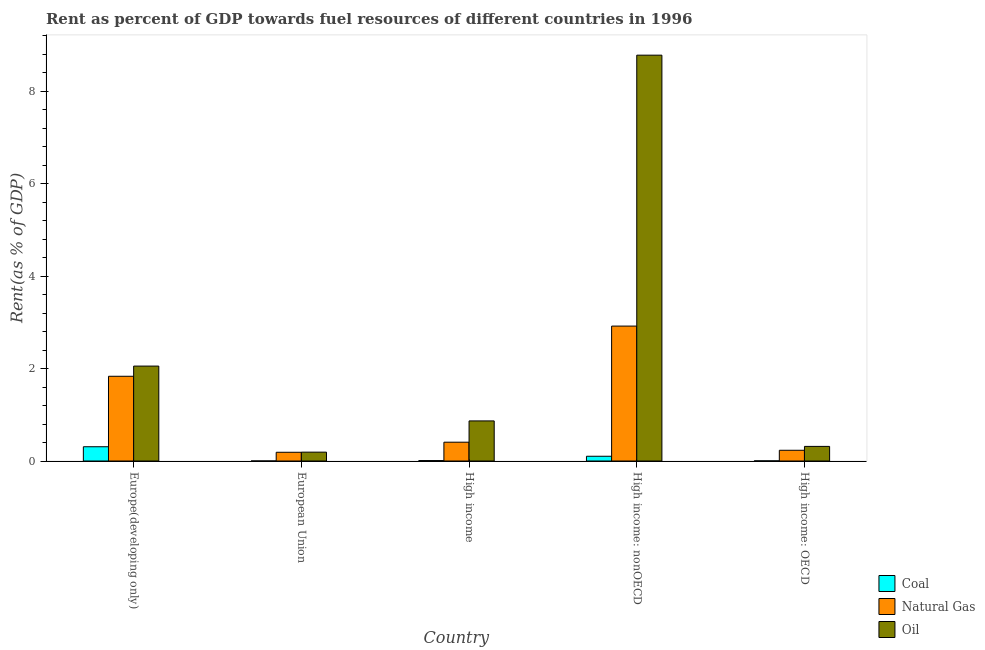How many different coloured bars are there?
Ensure brevity in your answer.  3. How many groups of bars are there?
Make the answer very short. 5. How many bars are there on the 2nd tick from the left?
Your response must be concise. 3. What is the label of the 3rd group of bars from the left?
Offer a terse response. High income. In how many cases, is the number of bars for a given country not equal to the number of legend labels?
Provide a short and direct response. 0. What is the rent towards oil in Europe(developing only)?
Offer a terse response. 2.05. Across all countries, what is the maximum rent towards natural gas?
Offer a very short reply. 2.92. Across all countries, what is the minimum rent towards coal?
Make the answer very short. 0. In which country was the rent towards natural gas maximum?
Provide a short and direct response. High income: nonOECD. What is the total rent towards oil in the graph?
Your response must be concise. 12.21. What is the difference between the rent towards coal in High income and that in High income: OECD?
Make the answer very short. 0.01. What is the difference between the rent towards oil in High income: OECD and the rent towards natural gas in High income?
Keep it short and to the point. -0.09. What is the average rent towards oil per country?
Ensure brevity in your answer.  2.44. What is the difference between the rent towards natural gas and rent towards coal in European Union?
Your response must be concise. 0.19. What is the ratio of the rent towards coal in Europe(developing only) to that in High income: nonOECD?
Your response must be concise. 3. Is the rent towards natural gas in High income less than that in High income: nonOECD?
Ensure brevity in your answer.  Yes. What is the difference between the highest and the second highest rent towards natural gas?
Your answer should be compact. 1.09. What is the difference between the highest and the lowest rent towards natural gas?
Provide a short and direct response. 2.73. What does the 2nd bar from the left in European Union represents?
Ensure brevity in your answer.  Natural Gas. What does the 3rd bar from the right in High income: nonOECD represents?
Offer a terse response. Coal. Is it the case that in every country, the sum of the rent towards coal and rent towards natural gas is greater than the rent towards oil?
Your answer should be compact. No. How many bars are there?
Make the answer very short. 15. Are all the bars in the graph horizontal?
Provide a short and direct response. No. Are the values on the major ticks of Y-axis written in scientific E-notation?
Provide a succinct answer. No. What is the title of the graph?
Make the answer very short. Rent as percent of GDP towards fuel resources of different countries in 1996. What is the label or title of the X-axis?
Make the answer very short. Country. What is the label or title of the Y-axis?
Your response must be concise. Rent(as % of GDP). What is the Rent(as % of GDP) of Coal in Europe(developing only)?
Keep it short and to the point. 0.31. What is the Rent(as % of GDP) of Natural Gas in Europe(developing only)?
Ensure brevity in your answer.  1.83. What is the Rent(as % of GDP) in Oil in Europe(developing only)?
Offer a very short reply. 2.05. What is the Rent(as % of GDP) of Coal in European Union?
Offer a very short reply. 0. What is the Rent(as % of GDP) of Natural Gas in European Union?
Give a very brief answer. 0.19. What is the Rent(as % of GDP) in Oil in European Union?
Keep it short and to the point. 0.19. What is the Rent(as % of GDP) of Coal in High income?
Your response must be concise. 0.01. What is the Rent(as % of GDP) of Natural Gas in High income?
Ensure brevity in your answer.  0.41. What is the Rent(as % of GDP) in Oil in High income?
Ensure brevity in your answer.  0.87. What is the Rent(as % of GDP) of Coal in High income: nonOECD?
Your answer should be compact. 0.1. What is the Rent(as % of GDP) in Natural Gas in High income: nonOECD?
Offer a very short reply. 2.92. What is the Rent(as % of GDP) of Oil in High income: nonOECD?
Provide a short and direct response. 8.78. What is the Rent(as % of GDP) of Coal in High income: OECD?
Keep it short and to the point. 0. What is the Rent(as % of GDP) of Natural Gas in High income: OECD?
Provide a short and direct response. 0.23. What is the Rent(as % of GDP) in Oil in High income: OECD?
Provide a succinct answer. 0.32. Across all countries, what is the maximum Rent(as % of GDP) in Coal?
Keep it short and to the point. 0.31. Across all countries, what is the maximum Rent(as % of GDP) in Natural Gas?
Give a very brief answer. 2.92. Across all countries, what is the maximum Rent(as % of GDP) of Oil?
Give a very brief answer. 8.78. Across all countries, what is the minimum Rent(as % of GDP) in Coal?
Your answer should be very brief. 0. Across all countries, what is the minimum Rent(as % of GDP) of Natural Gas?
Offer a terse response. 0.19. Across all countries, what is the minimum Rent(as % of GDP) in Oil?
Your answer should be very brief. 0.19. What is the total Rent(as % of GDP) of Coal in the graph?
Your answer should be very brief. 0.42. What is the total Rent(as % of GDP) of Natural Gas in the graph?
Ensure brevity in your answer.  5.58. What is the total Rent(as % of GDP) of Oil in the graph?
Your answer should be compact. 12.21. What is the difference between the Rent(as % of GDP) of Coal in Europe(developing only) and that in European Union?
Make the answer very short. 0.31. What is the difference between the Rent(as % of GDP) in Natural Gas in Europe(developing only) and that in European Union?
Offer a terse response. 1.64. What is the difference between the Rent(as % of GDP) in Oil in Europe(developing only) and that in European Union?
Keep it short and to the point. 1.86. What is the difference between the Rent(as % of GDP) in Coal in Europe(developing only) and that in High income?
Provide a short and direct response. 0.3. What is the difference between the Rent(as % of GDP) of Natural Gas in Europe(developing only) and that in High income?
Ensure brevity in your answer.  1.43. What is the difference between the Rent(as % of GDP) of Oil in Europe(developing only) and that in High income?
Keep it short and to the point. 1.19. What is the difference between the Rent(as % of GDP) in Coal in Europe(developing only) and that in High income: nonOECD?
Provide a short and direct response. 0.21. What is the difference between the Rent(as % of GDP) in Natural Gas in Europe(developing only) and that in High income: nonOECD?
Your answer should be very brief. -1.09. What is the difference between the Rent(as % of GDP) of Oil in Europe(developing only) and that in High income: nonOECD?
Provide a short and direct response. -6.72. What is the difference between the Rent(as % of GDP) of Coal in Europe(developing only) and that in High income: OECD?
Make the answer very short. 0.31. What is the difference between the Rent(as % of GDP) in Natural Gas in Europe(developing only) and that in High income: OECD?
Make the answer very short. 1.6. What is the difference between the Rent(as % of GDP) in Oil in Europe(developing only) and that in High income: OECD?
Offer a terse response. 1.74. What is the difference between the Rent(as % of GDP) of Coal in European Union and that in High income?
Your answer should be compact. -0.01. What is the difference between the Rent(as % of GDP) in Natural Gas in European Union and that in High income?
Your answer should be very brief. -0.22. What is the difference between the Rent(as % of GDP) in Oil in European Union and that in High income?
Provide a short and direct response. -0.68. What is the difference between the Rent(as % of GDP) of Coal in European Union and that in High income: nonOECD?
Your answer should be very brief. -0.1. What is the difference between the Rent(as % of GDP) of Natural Gas in European Union and that in High income: nonOECD?
Your answer should be compact. -2.73. What is the difference between the Rent(as % of GDP) of Oil in European Union and that in High income: nonOECD?
Your response must be concise. -8.59. What is the difference between the Rent(as % of GDP) in Coal in European Union and that in High income: OECD?
Provide a succinct answer. -0. What is the difference between the Rent(as % of GDP) in Natural Gas in European Union and that in High income: OECD?
Your answer should be compact. -0.04. What is the difference between the Rent(as % of GDP) of Oil in European Union and that in High income: OECD?
Your answer should be compact. -0.12. What is the difference between the Rent(as % of GDP) of Coal in High income and that in High income: nonOECD?
Your answer should be compact. -0.09. What is the difference between the Rent(as % of GDP) in Natural Gas in High income and that in High income: nonOECD?
Your answer should be compact. -2.51. What is the difference between the Rent(as % of GDP) of Oil in High income and that in High income: nonOECD?
Provide a short and direct response. -7.91. What is the difference between the Rent(as % of GDP) of Coal in High income and that in High income: OECD?
Your answer should be very brief. 0.01. What is the difference between the Rent(as % of GDP) in Natural Gas in High income and that in High income: OECD?
Provide a short and direct response. 0.17. What is the difference between the Rent(as % of GDP) of Oil in High income and that in High income: OECD?
Your response must be concise. 0.55. What is the difference between the Rent(as % of GDP) of Coal in High income: nonOECD and that in High income: OECD?
Your answer should be compact. 0.1. What is the difference between the Rent(as % of GDP) of Natural Gas in High income: nonOECD and that in High income: OECD?
Your response must be concise. 2.69. What is the difference between the Rent(as % of GDP) of Oil in High income: nonOECD and that in High income: OECD?
Ensure brevity in your answer.  8.46. What is the difference between the Rent(as % of GDP) of Coal in Europe(developing only) and the Rent(as % of GDP) of Natural Gas in European Union?
Your answer should be very brief. 0.12. What is the difference between the Rent(as % of GDP) of Coal in Europe(developing only) and the Rent(as % of GDP) of Oil in European Union?
Provide a short and direct response. 0.12. What is the difference between the Rent(as % of GDP) of Natural Gas in Europe(developing only) and the Rent(as % of GDP) of Oil in European Union?
Provide a short and direct response. 1.64. What is the difference between the Rent(as % of GDP) in Coal in Europe(developing only) and the Rent(as % of GDP) in Natural Gas in High income?
Make the answer very short. -0.1. What is the difference between the Rent(as % of GDP) of Coal in Europe(developing only) and the Rent(as % of GDP) of Oil in High income?
Keep it short and to the point. -0.56. What is the difference between the Rent(as % of GDP) of Natural Gas in Europe(developing only) and the Rent(as % of GDP) of Oil in High income?
Offer a terse response. 0.97. What is the difference between the Rent(as % of GDP) in Coal in Europe(developing only) and the Rent(as % of GDP) in Natural Gas in High income: nonOECD?
Offer a terse response. -2.61. What is the difference between the Rent(as % of GDP) in Coal in Europe(developing only) and the Rent(as % of GDP) in Oil in High income: nonOECD?
Keep it short and to the point. -8.47. What is the difference between the Rent(as % of GDP) of Natural Gas in Europe(developing only) and the Rent(as % of GDP) of Oil in High income: nonOECD?
Offer a terse response. -6.95. What is the difference between the Rent(as % of GDP) in Coal in Europe(developing only) and the Rent(as % of GDP) in Natural Gas in High income: OECD?
Offer a terse response. 0.08. What is the difference between the Rent(as % of GDP) in Coal in Europe(developing only) and the Rent(as % of GDP) in Oil in High income: OECD?
Ensure brevity in your answer.  -0.01. What is the difference between the Rent(as % of GDP) of Natural Gas in Europe(developing only) and the Rent(as % of GDP) of Oil in High income: OECD?
Keep it short and to the point. 1.52. What is the difference between the Rent(as % of GDP) of Coal in European Union and the Rent(as % of GDP) of Natural Gas in High income?
Your response must be concise. -0.41. What is the difference between the Rent(as % of GDP) of Coal in European Union and the Rent(as % of GDP) of Oil in High income?
Offer a terse response. -0.87. What is the difference between the Rent(as % of GDP) in Natural Gas in European Union and the Rent(as % of GDP) in Oil in High income?
Your answer should be very brief. -0.68. What is the difference between the Rent(as % of GDP) in Coal in European Union and the Rent(as % of GDP) in Natural Gas in High income: nonOECD?
Ensure brevity in your answer.  -2.92. What is the difference between the Rent(as % of GDP) of Coal in European Union and the Rent(as % of GDP) of Oil in High income: nonOECD?
Your answer should be compact. -8.78. What is the difference between the Rent(as % of GDP) in Natural Gas in European Union and the Rent(as % of GDP) in Oil in High income: nonOECD?
Your answer should be compact. -8.59. What is the difference between the Rent(as % of GDP) of Coal in European Union and the Rent(as % of GDP) of Natural Gas in High income: OECD?
Offer a very short reply. -0.23. What is the difference between the Rent(as % of GDP) in Coal in European Union and the Rent(as % of GDP) in Oil in High income: OECD?
Offer a very short reply. -0.32. What is the difference between the Rent(as % of GDP) in Natural Gas in European Union and the Rent(as % of GDP) in Oil in High income: OECD?
Your response must be concise. -0.13. What is the difference between the Rent(as % of GDP) of Coal in High income and the Rent(as % of GDP) of Natural Gas in High income: nonOECD?
Keep it short and to the point. -2.91. What is the difference between the Rent(as % of GDP) in Coal in High income and the Rent(as % of GDP) in Oil in High income: nonOECD?
Provide a succinct answer. -8.77. What is the difference between the Rent(as % of GDP) of Natural Gas in High income and the Rent(as % of GDP) of Oil in High income: nonOECD?
Provide a short and direct response. -8.37. What is the difference between the Rent(as % of GDP) in Coal in High income and the Rent(as % of GDP) in Natural Gas in High income: OECD?
Provide a short and direct response. -0.22. What is the difference between the Rent(as % of GDP) in Coal in High income and the Rent(as % of GDP) in Oil in High income: OECD?
Make the answer very short. -0.31. What is the difference between the Rent(as % of GDP) of Natural Gas in High income and the Rent(as % of GDP) of Oil in High income: OECD?
Offer a very short reply. 0.09. What is the difference between the Rent(as % of GDP) in Coal in High income: nonOECD and the Rent(as % of GDP) in Natural Gas in High income: OECD?
Keep it short and to the point. -0.13. What is the difference between the Rent(as % of GDP) in Coal in High income: nonOECD and the Rent(as % of GDP) in Oil in High income: OECD?
Offer a terse response. -0.21. What is the difference between the Rent(as % of GDP) of Natural Gas in High income: nonOECD and the Rent(as % of GDP) of Oil in High income: OECD?
Your response must be concise. 2.6. What is the average Rent(as % of GDP) in Coal per country?
Give a very brief answer. 0.08. What is the average Rent(as % of GDP) in Natural Gas per country?
Offer a very short reply. 1.12. What is the average Rent(as % of GDP) in Oil per country?
Offer a very short reply. 2.44. What is the difference between the Rent(as % of GDP) in Coal and Rent(as % of GDP) in Natural Gas in Europe(developing only)?
Your answer should be compact. -1.52. What is the difference between the Rent(as % of GDP) in Coal and Rent(as % of GDP) in Oil in Europe(developing only)?
Provide a short and direct response. -1.74. What is the difference between the Rent(as % of GDP) of Natural Gas and Rent(as % of GDP) of Oil in Europe(developing only)?
Give a very brief answer. -0.22. What is the difference between the Rent(as % of GDP) in Coal and Rent(as % of GDP) in Natural Gas in European Union?
Keep it short and to the point. -0.19. What is the difference between the Rent(as % of GDP) of Coal and Rent(as % of GDP) of Oil in European Union?
Offer a terse response. -0.19. What is the difference between the Rent(as % of GDP) in Natural Gas and Rent(as % of GDP) in Oil in European Union?
Your answer should be very brief. -0. What is the difference between the Rent(as % of GDP) in Coal and Rent(as % of GDP) in Natural Gas in High income?
Your answer should be very brief. -0.4. What is the difference between the Rent(as % of GDP) in Coal and Rent(as % of GDP) in Oil in High income?
Your response must be concise. -0.86. What is the difference between the Rent(as % of GDP) of Natural Gas and Rent(as % of GDP) of Oil in High income?
Provide a short and direct response. -0.46. What is the difference between the Rent(as % of GDP) in Coal and Rent(as % of GDP) in Natural Gas in High income: nonOECD?
Provide a short and direct response. -2.82. What is the difference between the Rent(as % of GDP) in Coal and Rent(as % of GDP) in Oil in High income: nonOECD?
Your answer should be very brief. -8.68. What is the difference between the Rent(as % of GDP) of Natural Gas and Rent(as % of GDP) of Oil in High income: nonOECD?
Offer a very short reply. -5.86. What is the difference between the Rent(as % of GDP) of Coal and Rent(as % of GDP) of Natural Gas in High income: OECD?
Provide a short and direct response. -0.23. What is the difference between the Rent(as % of GDP) in Coal and Rent(as % of GDP) in Oil in High income: OECD?
Give a very brief answer. -0.31. What is the difference between the Rent(as % of GDP) of Natural Gas and Rent(as % of GDP) of Oil in High income: OECD?
Offer a terse response. -0.08. What is the ratio of the Rent(as % of GDP) of Coal in Europe(developing only) to that in European Union?
Give a very brief answer. 603.68. What is the ratio of the Rent(as % of GDP) in Natural Gas in Europe(developing only) to that in European Union?
Offer a terse response. 9.7. What is the ratio of the Rent(as % of GDP) in Oil in Europe(developing only) to that in European Union?
Provide a succinct answer. 10.71. What is the ratio of the Rent(as % of GDP) of Coal in Europe(developing only) to that in High income?
Provide a succinct answer. 32.32. What is the ratio of the Rent(as % of GDP) in Natural Gas in Europe(developing only) to that in High income?
Provide a short and direct response. 4.5. What is the ratio of the Rent(as % of GDP) of Oil in Europe(developing only) to that in High income?
Keep it short and to the point. 2.37. What is the ratio of the Rent(as % of GDP) of Coal in Europe(developing only) to that in High income: nonOECD?
Your answer should be compact. 3. What is the ratio of the Rent(as % of GDP) in Natural Gas in Europe(developing only) to that in High income: nonOECD?
Ensure brevity in your answer.  0.63. What is the ratio of the Rent(as % of GDP) in Oil in Europe(developing only) to that in High income: nonOECD?
Your response must be concise. 0.23. What is the ratio of the Rent(as % of GDP) of Coal in Europe(developing only) to that in High income: OECD?
Provide a short and direct response. 101.25. What is the ratio of the Rent(as % of GDP) in Natural Gas in Europe(developing only) to that in High income: OECD?
Keep it short and to the point. 7.9. What is the ratio of the Rent(as % of GDP) of Oil in Europe(developing only) to that in High income: OECD?
Ensure brevity in your answer.  6.5. What is the ratio of the Rent(as % of GDP) in Coal in European Union to that in High income?
Your response must be concise. 0.05. What is the ratio of the Rent(as % of GDP) of Natural Gas in European Union to that in High income?
Provide a short and direct response. 0.46. What is the ratio of the Rent(as % of GDP) of Oil in European Union to that in High income?
Offer a very short reply. 0.22. What is the ratio of the Rent(as % of GDP) of Coal in European Union to that in High income: nonOECD?
Your answer should be very brief. 0.01. What is the ratio of the Rent(as % of GDP) of Natural Gas in European Union to that in High income: nonOECD?
Offer a terse response. 0.06. What is the ratio of the Rent(as % of GDP) of Oil in European Union to that in High income: nonOECD?
Provide a succinct answer. 0.02. What is the ratio of the Rent(as % of GDP) of Coal in European Union to that in High income: OECD?
Provide a short and direct response. 0.17. What is the ratio of the Rent(as % of GDP) of Natural Gas in European Union to that in High income: OECD?
Your answer should be compact. 0.81. What is the ratio of the Rent(as % of GDP) in Oil in European Union to that in High income: OECD?
Make the answer very short. 0.61. What is the ratio of the Rent(as % of GDP) in Coal in High income to that in High income: nonOECD?
Your response must be concise. 0.09. What is the ratio of the Rent(as % of GDP) in Natural Gas in High income to that in High income: nonOECD?
Make the answer very short. 0.14. What is the ratio of the Rent(as % of GDP) of Oil in High income to that in High income: nonOECD?
Make the answer very short. 0.1. What is the ratio of the Rent(as % of GDP) in Coal in High income to that in High income: OECD?
Provide a short and direct response. 3.13. What is the ratio of the Rent(as % of GDP) of Natural Gas in High income to that in High income: OECD?
Keep it short and to the point. 1.75. What is the ratio of the Rent(as % of GDP) in Oil in High income to that in High income: OECD?
Your answer should be compact. 2.74. What is the ratio of the Rent(as % of GDP) in Coal in High income: nonOECD to that in High income: OECD?
Make the answer very short. 33.73. What is the ratio of the Rent(as % of GDP) of Natural Gas in High income: nonOECD to that in High income: OECD?
Offer a very short reply. 12.58. What is the ratio of the Rent(as % of GDP) of Oil in High income: nonOECD to that in High income: OECD?
Offer a terse response. 27.78. What is the difference between the highest and the second highest Rent(as % of GDP) of Coal?
Keep it short and to the point. 0.21. What is the difference between the highest and the second highest Rent(as % of GDP) in Natural Gas?
Give a very brief answer. 1.09. What is the difference between the highest and the second highest Rent(as % of GDP) in Oil?
Your answer should be compact. 6.72. What is the difference between the highest and the lowest Rent(as % of GDP) of Coal?
Keep it short and to the point. 0.31. What is the difference between the highest and the lowest Rent(as % of GDP) in Natural Gas?
Make the answer very short. 2.73. What is the difference between the highest and the lowest Rent(as % of GDP) in Oil?
Give a very brief answer. 8.59. 